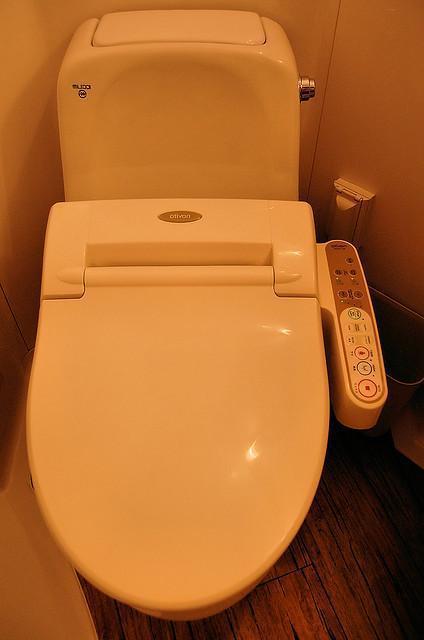How many birds have their wings spread?
Give a very brief answer. 0. 